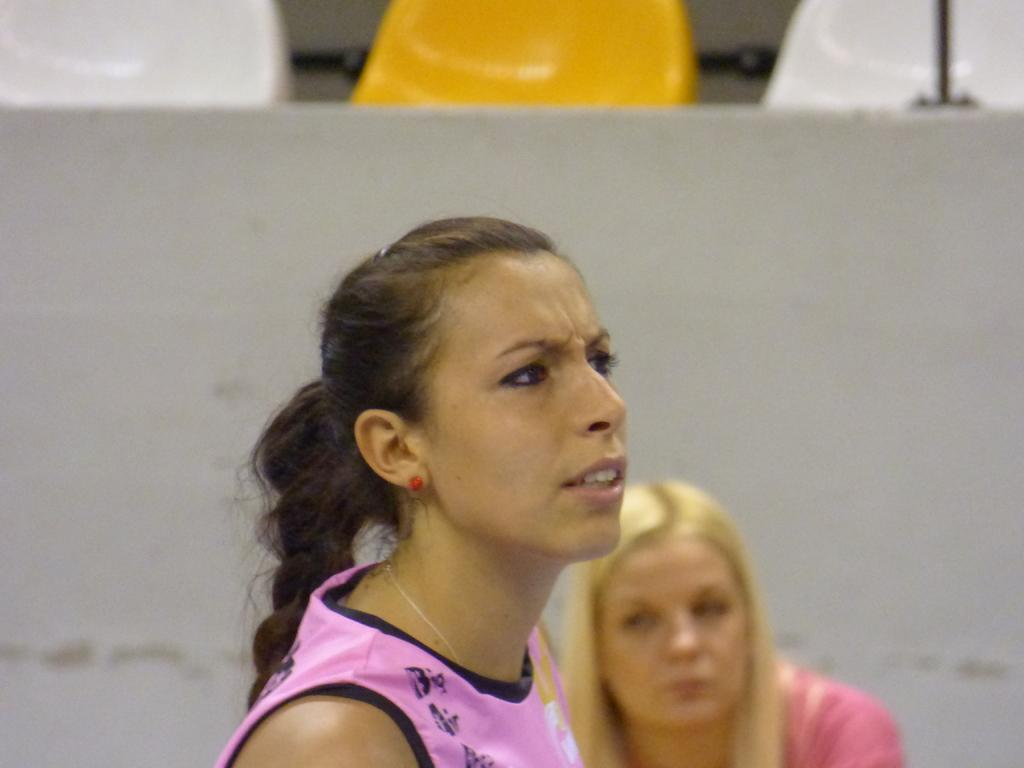Where was the image taken? The image was taken outdoors. What can be seen in the background of the image? There are empty chairs and a wall in the background. How many women are in the image? There are two women at the bottom of the image. What type of waste can be seen on the shelf in the image? There is no shelf or waste present in the image. 